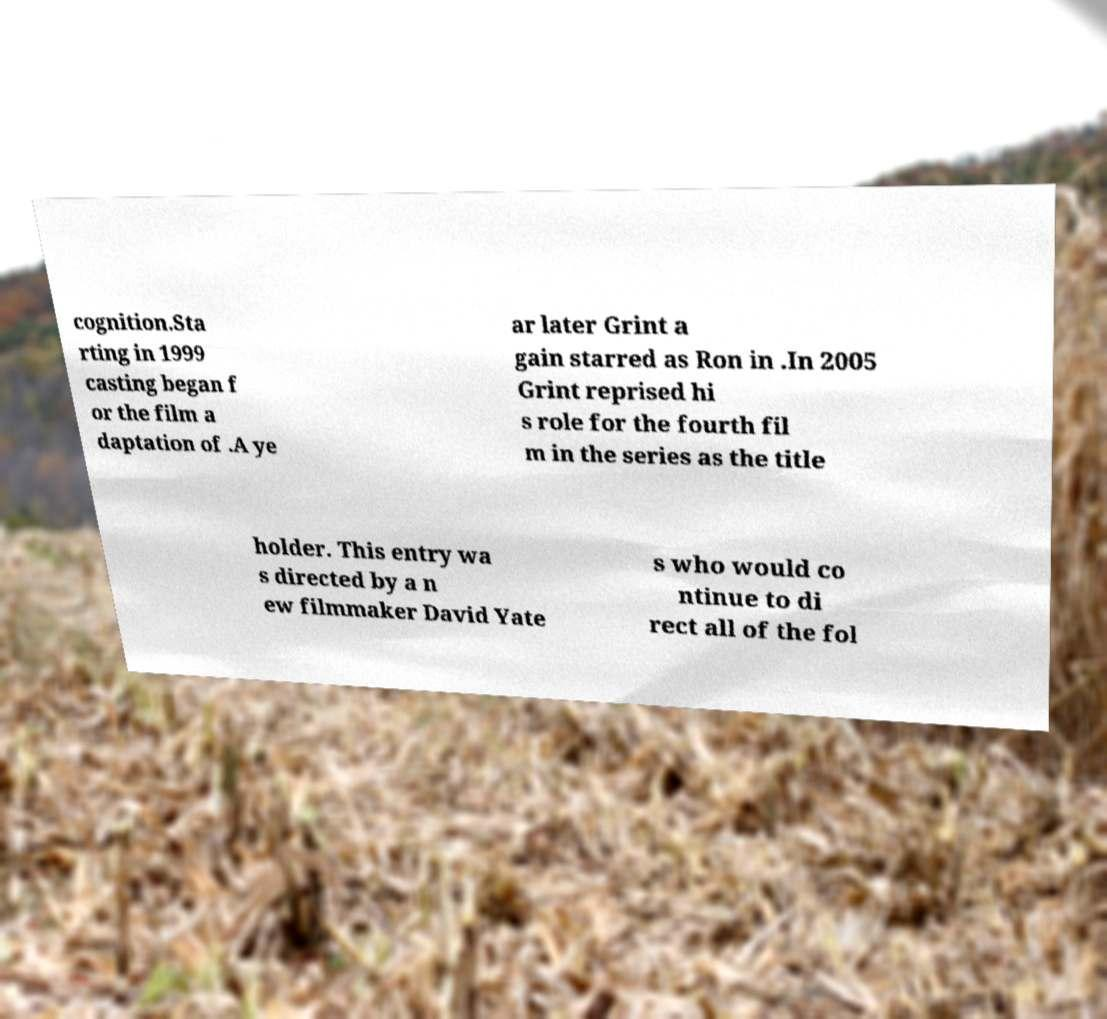For documentation purposes, I need the text within this image transcribed. Could you provide that? cognition.Sta rting in 1999 casting began f or the film a daptation of .A ye ar later Grint a gain starred as Ron in .In 2005 Grint reprised hi s role for the fourth fil m in the series as the title holder. This entry wa s directed by a n ew filmmaker David Yate s who would co ntinue to di rect all of the fol 